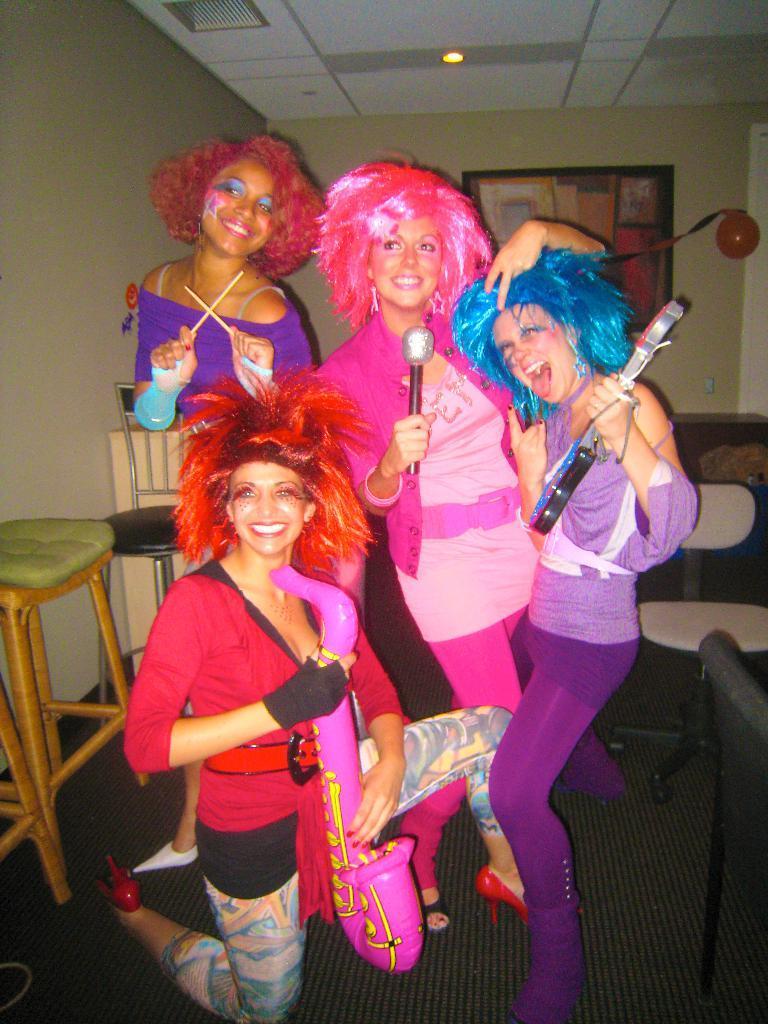How would you summarize this image in a sentence or two? In this picture we can see four girls here, on the left side there is a chair, we can see a wall in the background, there is a portrait and a balloon here, we can see the ceiling at the top of the picture, there is a light here. 